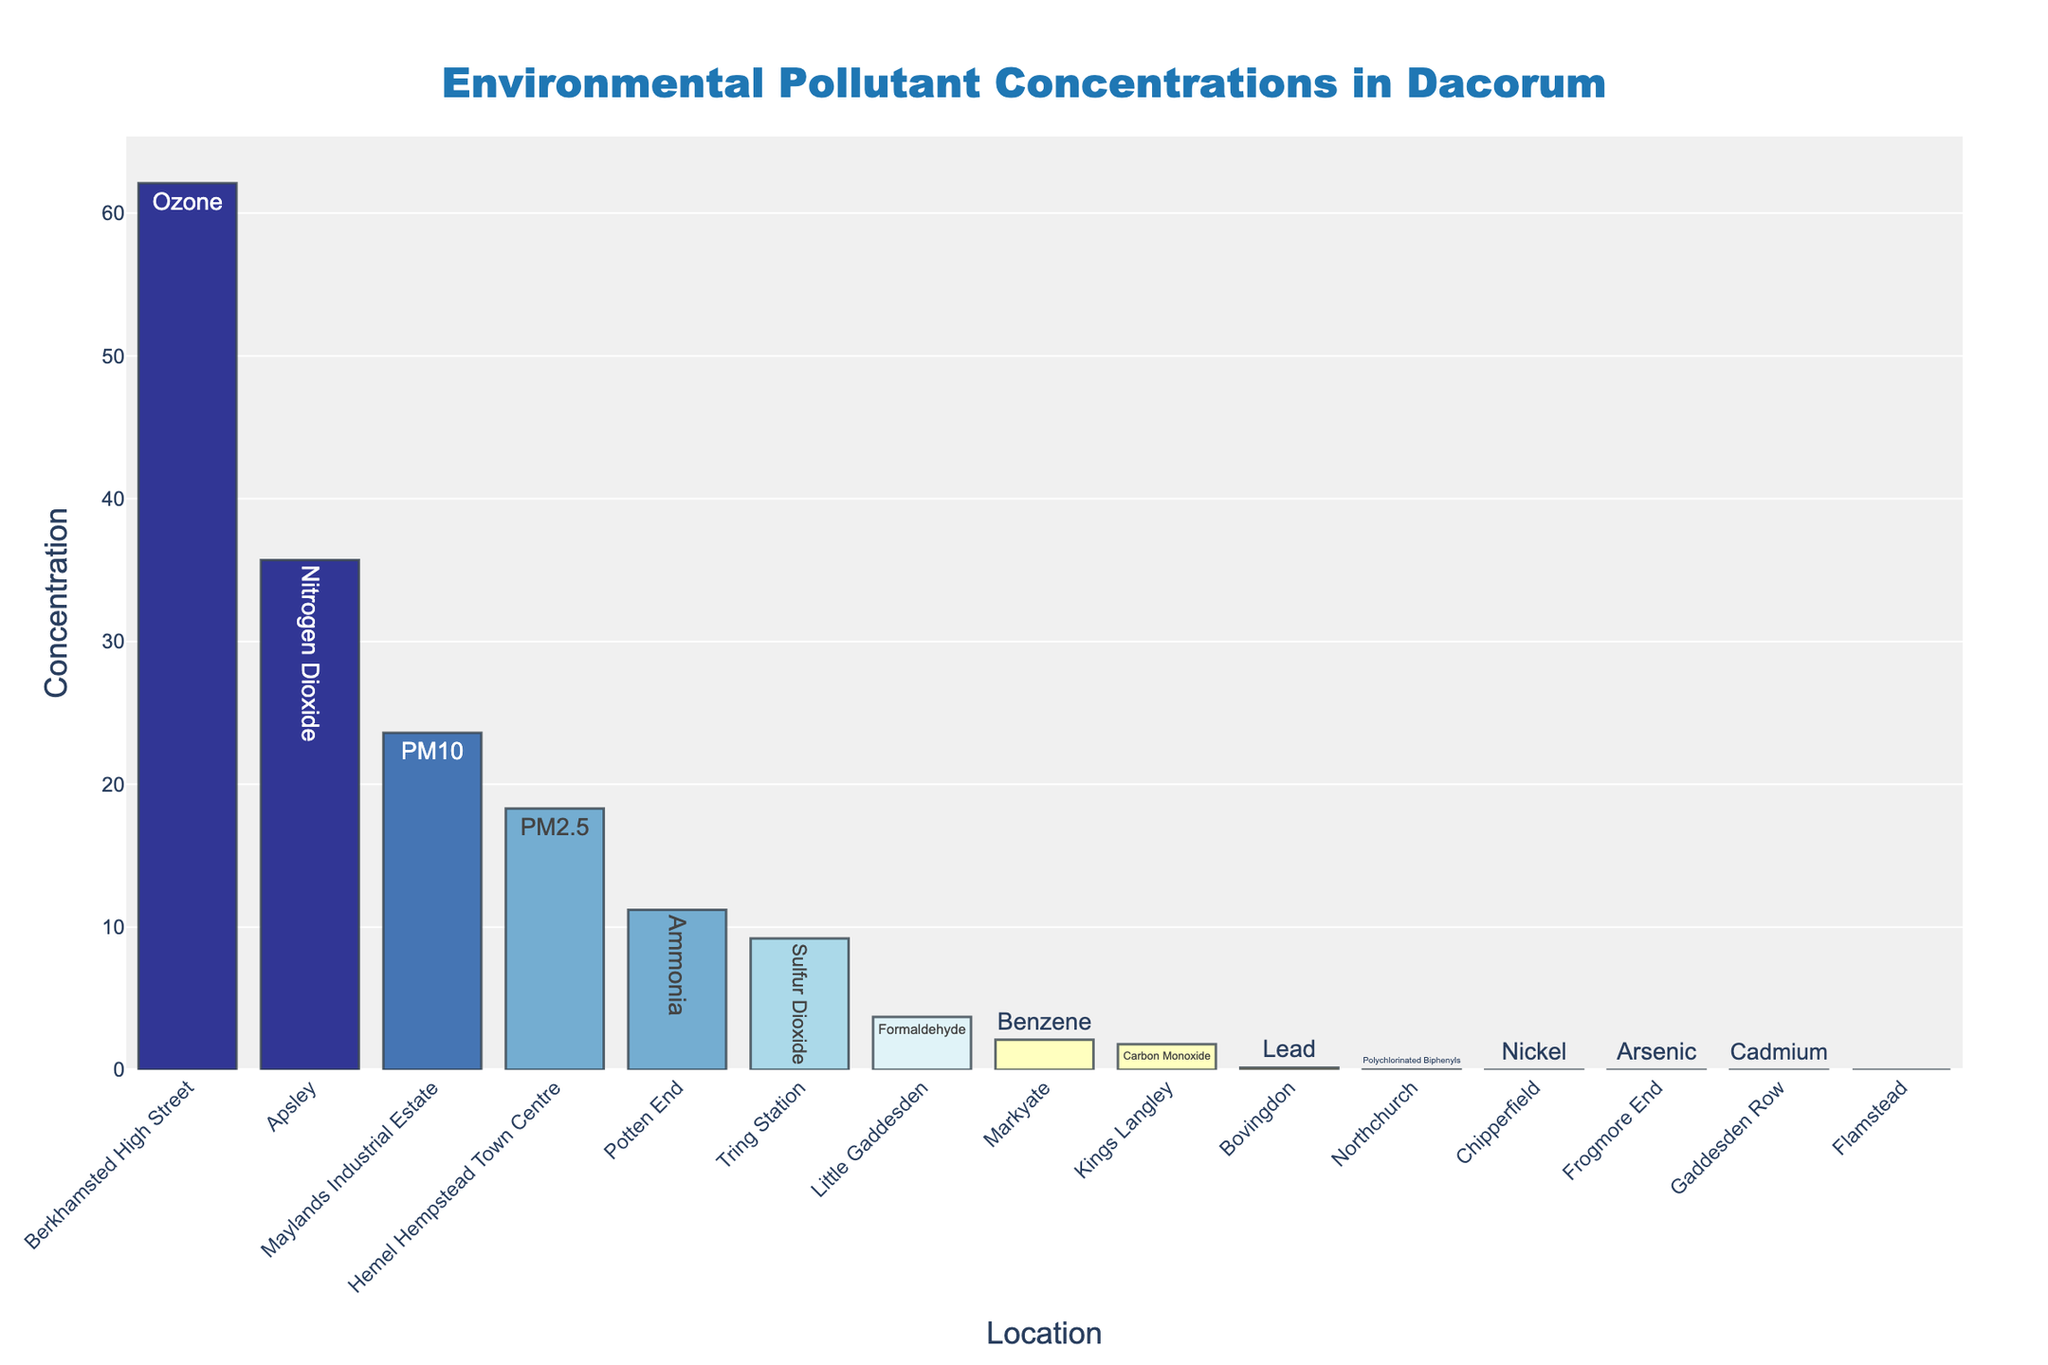What is the highest pollutant concentration on the plot, and which location does it correspond to? The highest bar indicates the highest pollutant concentration. According to the plot, the highest bar corresponds to Berkhamsted High Street with an ozone concentration of 62.1.
Answer: 62.1, Berkhamsted High Street Which location has the lowest pollutant concentration, and what is the pollutant? The lowest bar on the plot represents the lowest concentration. The plot shows that Flamstead has the lowest concentration of Benzo(a)pyrene at 0.0004.
Answer: Flamstead, Benzo(a)pyrene How many locations have pollutant concentrations higher than 20? Count the bars that exceed the 20 mark on the y-axis. These locations are Hemel Hempstead Town Centre, Apsley, Berkhamsted High Street, and Maylands Industrial Estate. There are 4 such locations.
Answer: 4 locations Which two locations have pollutants with concentrations closest to 10? Look for bars that are close to the 10 mark on the y-axis. Tring Station has sulfur dioxide with a concentration of 9.2, and Potten End has ammonia with a concentration of 11.2, both close to 10.
Answer: Tring Station and Potten End Which pollutant has the lowest concentration, and in which location is it found? Identify the smallest value on the y-axis. The lowest concentration is Cadmium, found in Gaddesden Row with a concentration of 0.001.
Answer: Cadmium, Gaddesden Row What is the total concentration of pollutants in Maylands Industrial Estate and Apsley? Add the concentrations of pollutants in both locations: Maylands Industrial Estate (PM10, 23.6) and Apsley (Nitrogen Dioxide, 35.7). The total is 23.6 + 35.7 = 59.3.
Answer: 59.3 Which locations have concentrations between 1 and 5, and what are the pollutants? Identify the bars within the range of 1 to 5 on the y-axis. Kings Langley (Carbon Monoxide, 1.8) and Markyate (Benzene, 2.1) fall into this range.
Answer: Kings Langley (Carbon Monoxide), Markyate (Benzene) Compare the concentration of pollutants in Hemel Hempstead Town Centre and Little Gaddesden. Which has higher, and by how much? Subtract the lower concentration from the higher one: Hemel Hempstead Town Centre (PM2.5, 18.3) and Little Gaddesden (Formaldehyde, 3.7). 18.3 - 3.7 = 14.6, so Hemel Hempstead Town Centre has a higher concentration by 14.6.
Answer: Hemel Hempstead Town Centre, 14.6 